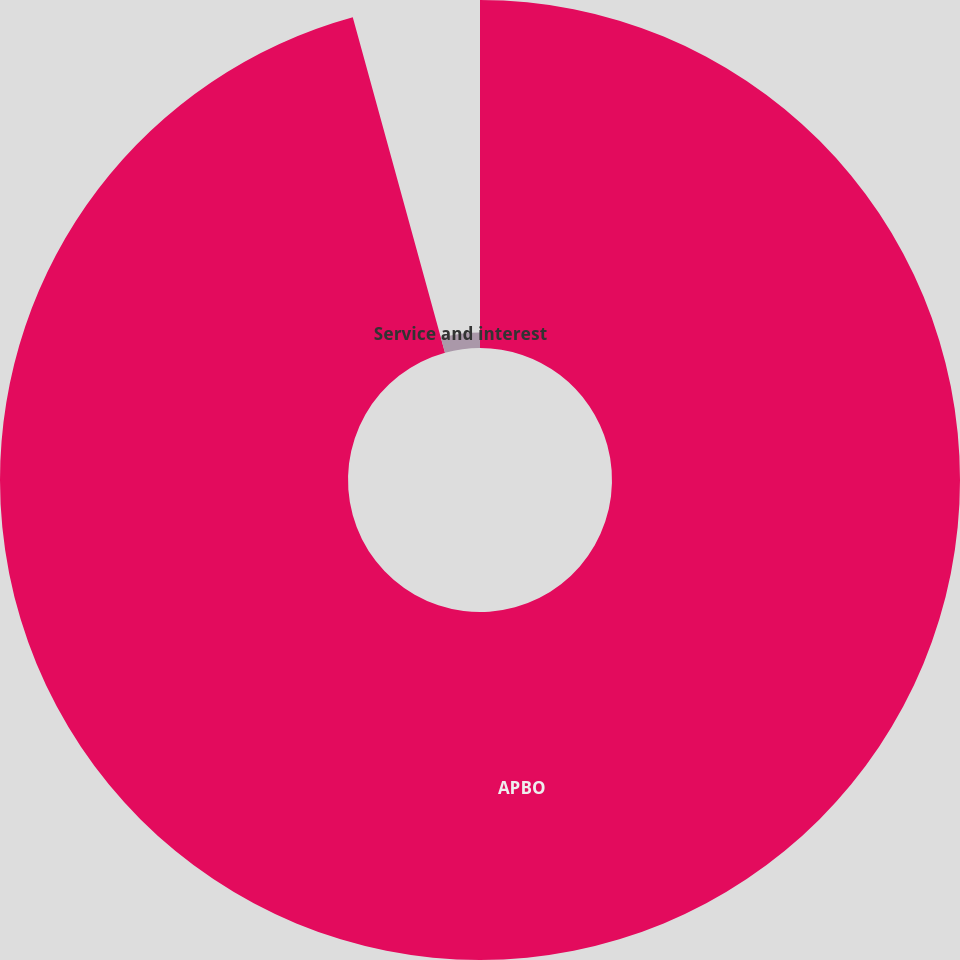<chart> <loc_0><loc_0><loc_500><loc_500><pie_chart><fcel>APBO<fcel>Service and interest<nl><fcel>95.73%<fcel>4.27%<nl></chart> 